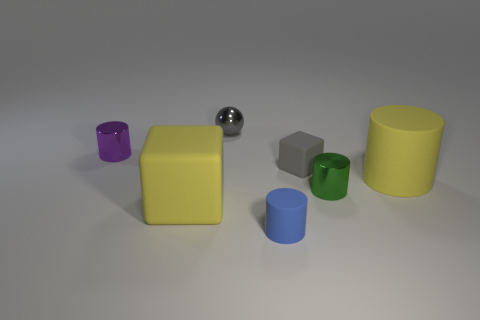Subtract all blue cylinders. Subtract all yellow cubes. How many cylinders are left? 3 Add 1 green metallic cylinders. How many objects exist? 8 Subtract all blocks. How many objects are left? 5 Subtract all metal things. Subtract all tiny rubber cylinders. How many objects are left? 3 Add 5 big yellow rubber blocks. How many big yellow rubber blocks are left? 6 Add 1 cyan cylinders. How many cyan cylinders exist? 1 Subtract 0 purple cubes. How many objects are left? 7 